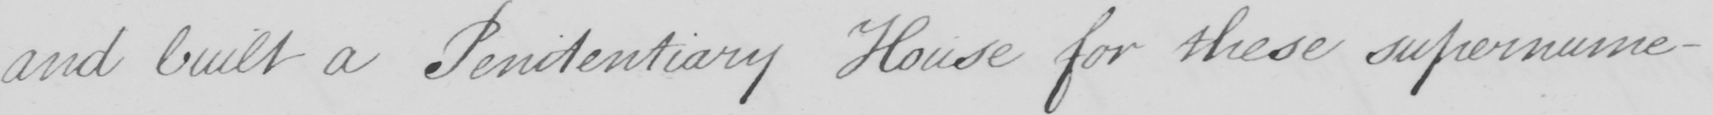What text is written in this handwritten line? and built a Penitentiary House for these supernume- 